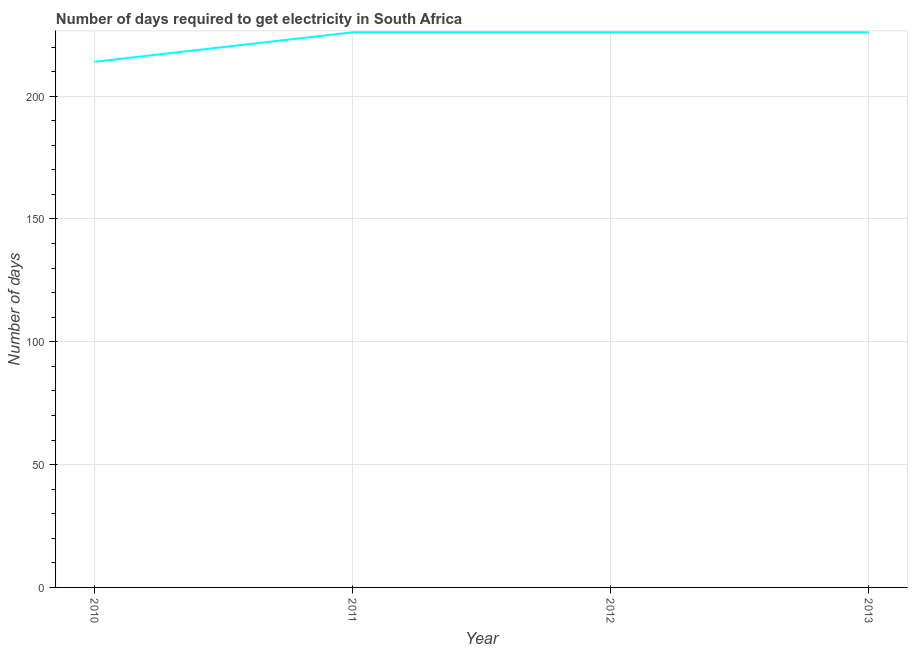What is the time to get electricity in 2013?
Your answer should be compact. 226. Across all years, what is the maximum time to get electricity?
Offer a terse response. 226. Across all years, what is the minimum time to get electricity?
Ensure brevity in your answer.  214. In which year was the time to get electricity maximum?
Your answer should be compact. 2011. In which year was the time to get electricity minimum?
Offer a terse response. 2010. What is the sum of the time to get electricity?
Your response must be concise. 892. What is the difference between the time to get electricity in 2010 and 2011?
Provide a short and direct response. -12. What is the average time to get electricity per year?
Offer a terse response. 223. What is the median time to get electricity?
Offer a very short reply. 226. In how many years, is the time to get electricity greater than 40 ?
Keep it short and to the point. 4. Do a majority of the years between 2010 and 2012 (inclusive) have time to get electricity greater than 160 ?
Offer a terse response. Yes. What is the ratio of the time to get electricity in 2011 to that in 2012?
Offer a terse response. 1. Is the time to get electricity in 2011 less than that in 2012?
Your answer should be compact. No. What is the difference between the highest and the second highest time to get electricity?
Offer a very short reply. 0. Is the sum of the time to get electricity in 2012 and 2013 greater than the maximum time to get electricity across all years?
Provide a succinct answer. Yes. What is the difference between the highest and the lowest time to get electricity?
Offer a terse response. 12. In how many years, is the time to get electricity greater than the average time to get electricity taken over all years?
Keep it short and to the point. 3. Does the time to get electricity monotonically increase over the years?
Provide a short and direct response. No. How many lines are there?
Your response must be concise. 1. What is the difference between two consecutive major ticks on the Y-axis?
Offer a very short reply. 50. Are the values on the major ticks of Y-axis written in scientific E-notation?
Make the answer very short. No. Does the graph contain any zero values?
Your answer should be very brief. No. Does the graph contain grids?
Make the answer very short. Yes. What is the title of the graph?
Give a very brief answer. Number of days required to get electricity in South Africa. What is the label or title of the Y-axis?
Make the answer very short. Number of days. What is the Number of days of 2010?
Give a very brief answer. 214. What is the Number of days in 2011?
Make the answer very short. 226. What is the Number of days in 2012?
Offer a terse response. 226. What is the Number of days of 2013?
Provide a short and direct response. 226. What is the difference between the Number of days in 2010 and 2011?
Your answer should be very brief. -12. What is the difference between the Number of days in 2011 and 2012?
Your response must be concise. 0. What is the ratio of the Number of days in 2010 to that in 2011?
Offer a very short reply. 0.95. What is the ratio of the Number of days in 2010 to that in 2012?
Your response must be concise. 0.95. What is the ratio of the Number of days in 2010 to that in 2013?
Provide a short and direct response. 0.95. What is the ratio of the Number of days in 2011 to that in 2012?
Ensure brevity in your answer.  1. What is the ratio of the Number of days in 2012 to that in 2013?
Provide a succinct answer. 1. 